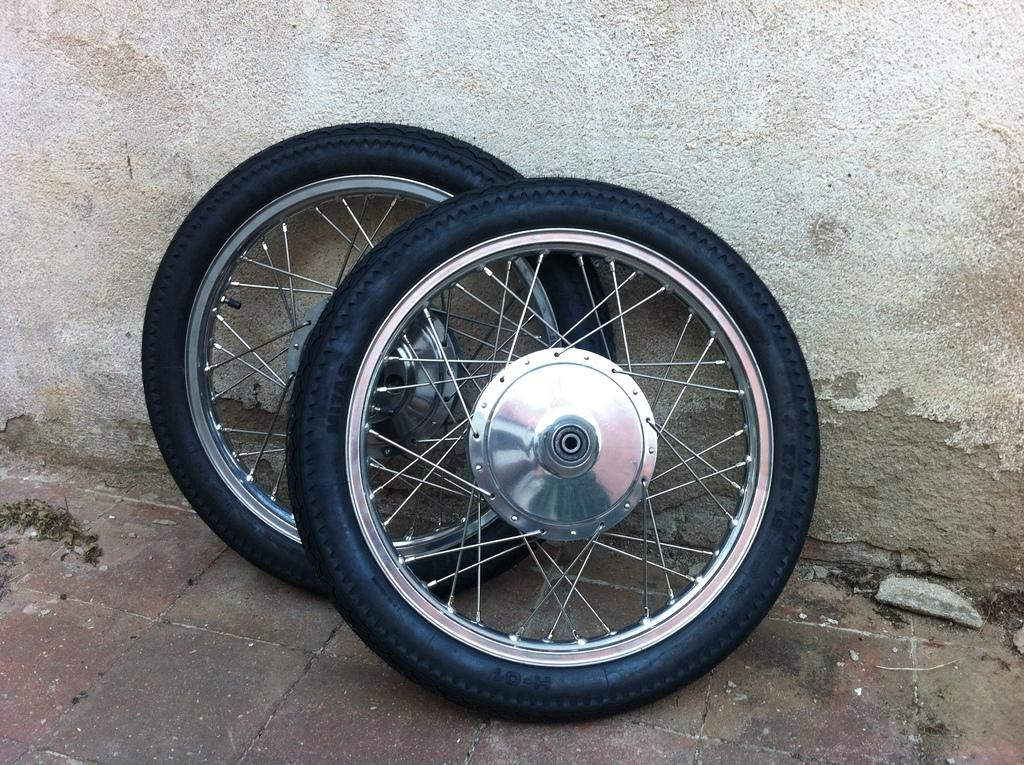What type of surface is visible in the image? There is ground visible in the image. What objects are on the ground? There are two wheels on the ground. How are the wheels positioned in relation to the wall? The wheels are leaned against a wall. What type of tax is being discussed in the image? There is no discussion of tax in the image; it features two wheels leaned against a wall. 